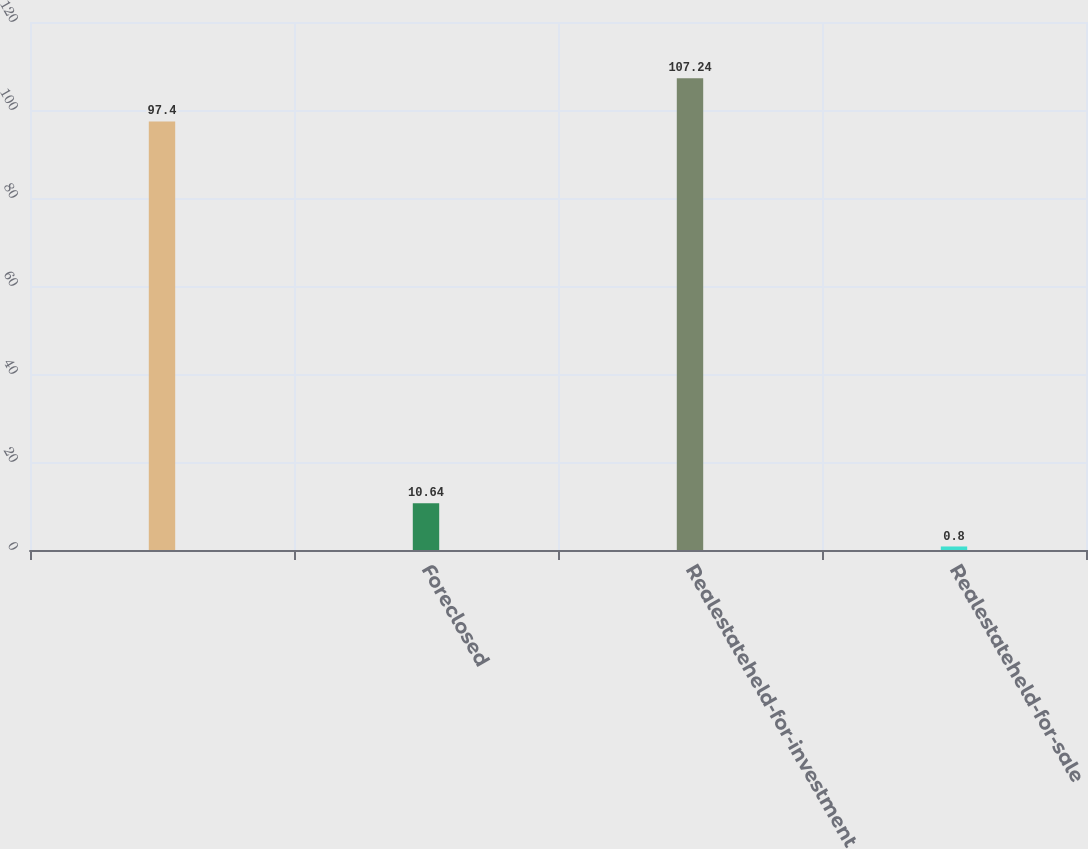Convert chart to OTSL. <chart><loc_0><loc_0><loc_500><loc_500><bar_chart><ecel><fcel>Foreclosed<fcel>Realestateheld-for-investment<fcel>Realestateheld-for-sale<nl><fcel>97.4<fcel>10.64<fcel>107.24<fcel>0.8<nl></chart> 